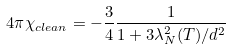Convert formula to latex. <formula><loc_0><loc_0><loc_500><loc_500>4 \pi \chi _ { c l e a n } = - \frac { 3 } { 4 } \frac { 1 } { 1 + 3 \lambda _ { N } ^ { 2 } ( T ) / d ^ { 2 } }</formula> 